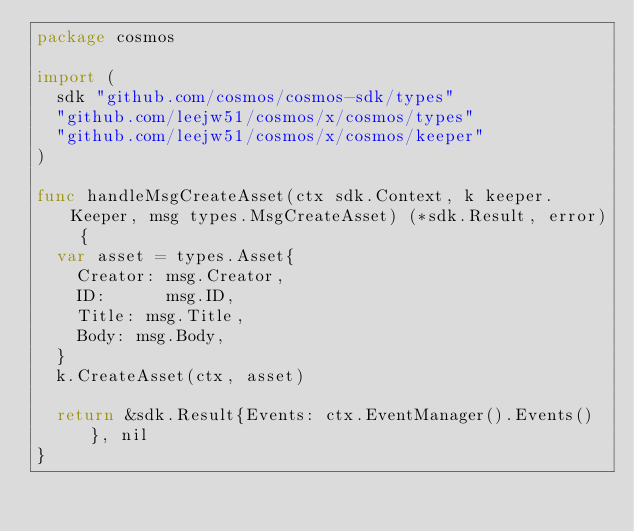Convert code to text. <code><loc_0><loc_0><loc_500><loc_500><_Go_>package cosmos

import (
	sdk "github.com/cosmos/cosmos-sdk/types"
	"github.com/leejw51/cosmos/x/cosmos/types"
	"github.com/leejw51/cosmos/x/cosmos/keeper"
)

func handleMsgCreateAsset(ctx sdk.Context, k keeper.Keeper, msg types.MsgCreateAsset) (*sdk.Result, error) {
	var asset = types.Asset{
		Creator: msg.Creator,
		ID:      msg.ID,
    Title: msg.Title,
    Body: msg.Body,
	}
	k.CreateAsset(ctx, asset)

	return &sdk.Result{Events: ctx.EventManager().Events()}, nil
}
</code> 